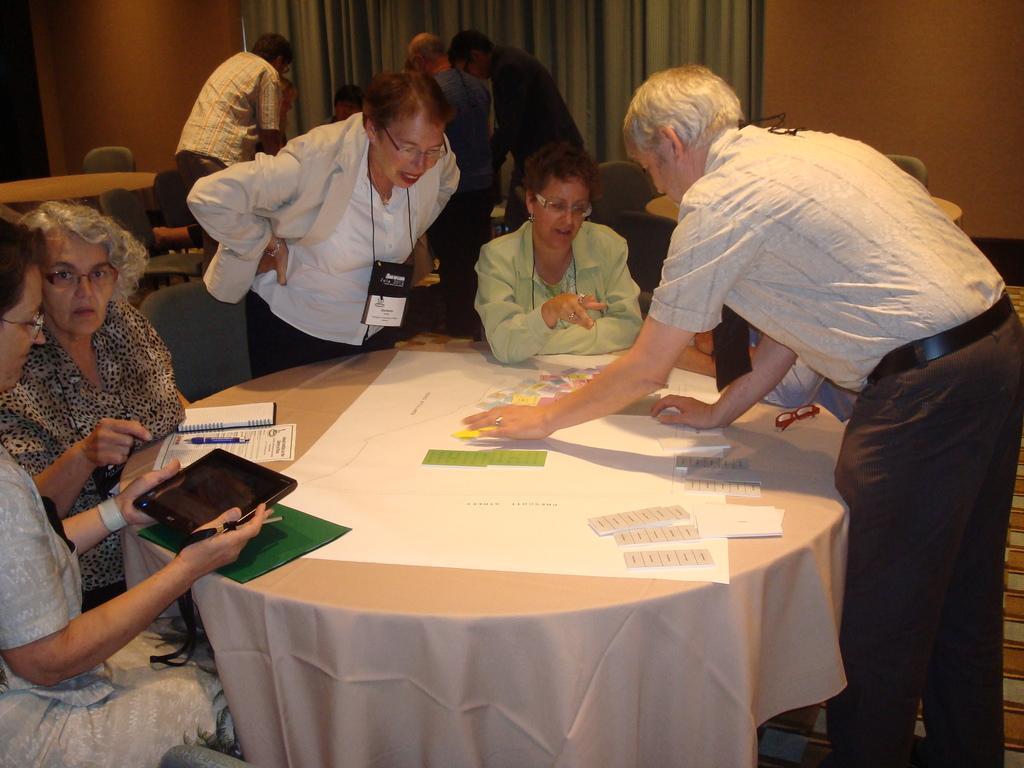Describe this image in one or two sentences. In this image i can see few women siting on chairs around the table and few persons standing, i can see a tab in one of the woman's hands. On the table i can see few papers, a spectacles and a pen. In the background i can see few other people standing, a table, and few empty chairs , the wall and the curtain. 